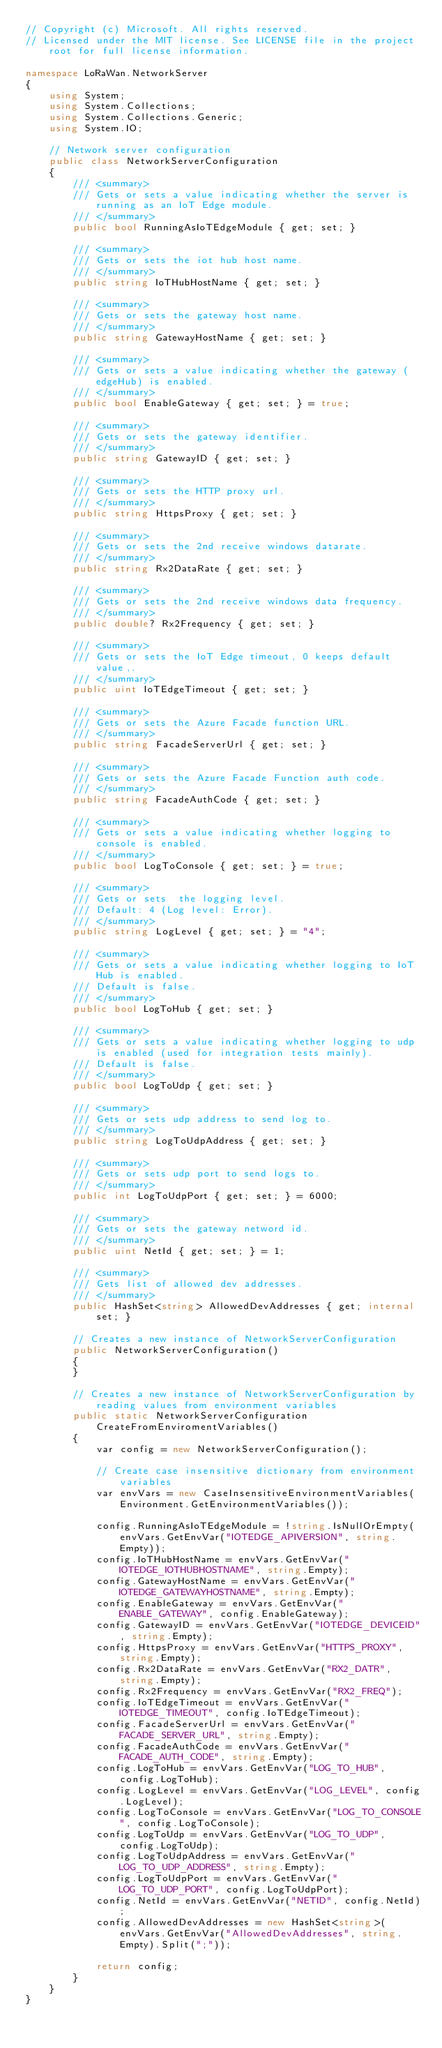<code> <loc_0><loc_0><loc_500><loc_500><_C#_>// Copyright (c) Microsoft. All rights reserved.
// Licensed under the MIT license. See LICENSE file in the project root for full license information.

namespace LoRaWan.NetworkServer
{
    using System;
    using System.Collections;
    using System.Collections.Generic;
    using System.IO;

    // Network server configuration
    public class NetworkServerConfiguration
    {
        /// <summary>
        /// Gets or sets a value indicating whether the server is running as an IoT Edge module.
        /// </summary>
        public bool RunningAsIoTEdgeModule { get; set; }

        /// <summary>
        /// Gets or sets the iot hub host name.
        /// </summary>
        public string IoTHubHostName { get; set; }

        /// <summary>
        /// Gets or sets the gateway host name.
        /// </summary>
        public string GatewayHostName { get; set; }

        /// <summary>
        /// Gets or sets a value indicating whether the gateway (edgeHub) is enabled.
        /// </summary>
        public bool EnableGateway { get; set; } = true;

        /// <summary>
        /// Gets or sets the gateway identifier.
        /// </summary>
        public string GatewayID { get; set; }

        /// <summary>
        /// Gets or sets the HTTP proxy url.
        /// </summary>
        public string HttpsProxy { get; set; }

        /// <summary>
        /// Gets or sets the 2nd receive windows datarate.
        /// </summary>
        public string Rx2DataRate { get; set; }

        /// <summary>
        /// Gets or sets the 2nd receive windows data frequency.
        /// </summary>
        public double? Rx2Frequency { get; set; }

        /// <summary>
        /// Gets or sets the IoT Edge timeout, 0 keeps default value,.
        /// </summary>
        public uint IoTEdgeTimeout { get; set; }

        /// <summary>
        /// Gets or sets the Azure Facade function URL.
        /// </summary>
        public string FacadeServerUrl { get; set; }

        /// <summary>
        /// Gets or sets the Azure Facade Function auth code.
        /// </summary>
        public string FacadeAuthCode { get; set; }

        /// <summary>
        /// Gets or sets a value indicating whether logging to console is enabled.
        /// </summary>
        public bool LogToConsole { get; set; } = true;

        /// <summary>
        /// Gets or sets  the logging level.
        /// Default: 4 (Log level: Error).
        /// </summary>
        public string LogLevel { get; set; } = "4";

        /// <summary>
        /// Gets or sets a value indicating whether logging to IoT Hub is enabled.
        /// Default is false.
        /// </summary>
        public bool LogToHub { get; set; }

        /// <summary>
        /// Gets or sets a value indicating whether logging to udp is enabled (used for integration tests mainly).
        /// Default is false.
        /// </summary>
        public bool LogToUdp { get; set; }

        /// <summary>
        /// Gets or sets udp address to send log to.
        /// </summary>
        public string LogToUdpAddress { get; set; }

        /// <summary>
        /// Gets or sets udp port to send logs to.
        /// </summary>
        public int LogToUdpPort { get; set; } = 6000;

        /// <summary>
        /// Gets or sets the gateway netword id.
        /// </summary>
        public uint NetId { get; set; } = 1;

        /// <summary>
        /// Gets list of allowed dev addresses.
        /// </summary>
        public HashSet<string> AllowedDevAddresses { get; internal set; }

        // Creates a new instance of NetworkServerConfiguration
        public NetworkServerConfiguration()
        {
        }

        // Creates a new instance of NetworkServerConfiguration by reading values from environment variables
        public static NetworkServerConfiguration CreateFromEnviromentVariables()
        {
            var config = new NetworkServerConfiguration();

            // Create case insensitive dictionary from environment variables
            var envVars = new CaseInsensitiveEnvironmentVariables(Environment.GetEnvironmentVariables());

            config.RunningAsIoTEdgeModule = !string.IsNullOrEmpty(envVars.GetEnvVar("IOTEDGE_APIVERSION", string.Empty));
            config.IoTHubHostName = envVars.GetEnvVar("IOTEDGE_IOTHUBHOSTNAME", string.Empty);
            config.GatewayHostName = envVars.GetEnvVar("IOTEDGE_GATEWAYHOSTNAME", string.Empty);
            config.EnableGateway = envVars.GetEnvVar("ENABLE_GATEWAY", config.EnableGateway);
            config.GatewayID = envVars.GetEnvVar("IOTEDGE_DEVICEID", string.Empty);
            config.HttpsProxy = envVars.GetEnvVar("HTTPS_PROXY", string.Empty);
            config.Rx2DataRate = envVars.GetEnvVar("RX2_DATR", string.Empty);
            config.Rx2Frequency = envVars.GetEnvVar("RX2_FREQ");
            config.IoTEdgeTimeout = envVars.GetEnvVar("IOTEDGE_TIMEOUT", config.IoTEdgeTimeout);
            config.FacadeServerUrl = envVars.GetEnvVar("FACADE_SERVER_URL", string.Empty);
            config.FacadeAuthCode = envVars.GetEnvVar("FACADE_AUTH_CODE", string.Empty);
            config.LogToHub = envVars.GetEnvVar("LOG_TO_HUB", config.LogToHub);
            config.LogLevel = envVars.GetEnvVar("LOG_LEVEL", config.LogLevel);
            config.LogToConsole = envVars.GetEnvVar("LOG_TO_CONSOLE", config.LogToConsole);
            config.LogToUdp = envVars.GetEnvVar("LOG_TO_UDP", config.LogToUdp);
            config.LogToUdpAddress = envVars.GetEnvVar("LOG_TO_UDP_ADDRESS", string.Empty);
            config.LogToUdpPort = envVars.GetEnvVar("LOG_TO_UDP_PORT", config.LogToUdpPort);
            config.NetId = envVars.GetEnvVar("NETID", config.NetId);
            config.AllowedDevAddresses = new HashSet<string>(envVars.GetEnvVar("AllowedDevAddresses", string.Empty).Split(";"));

            return config;
        }
    }
}</code> 